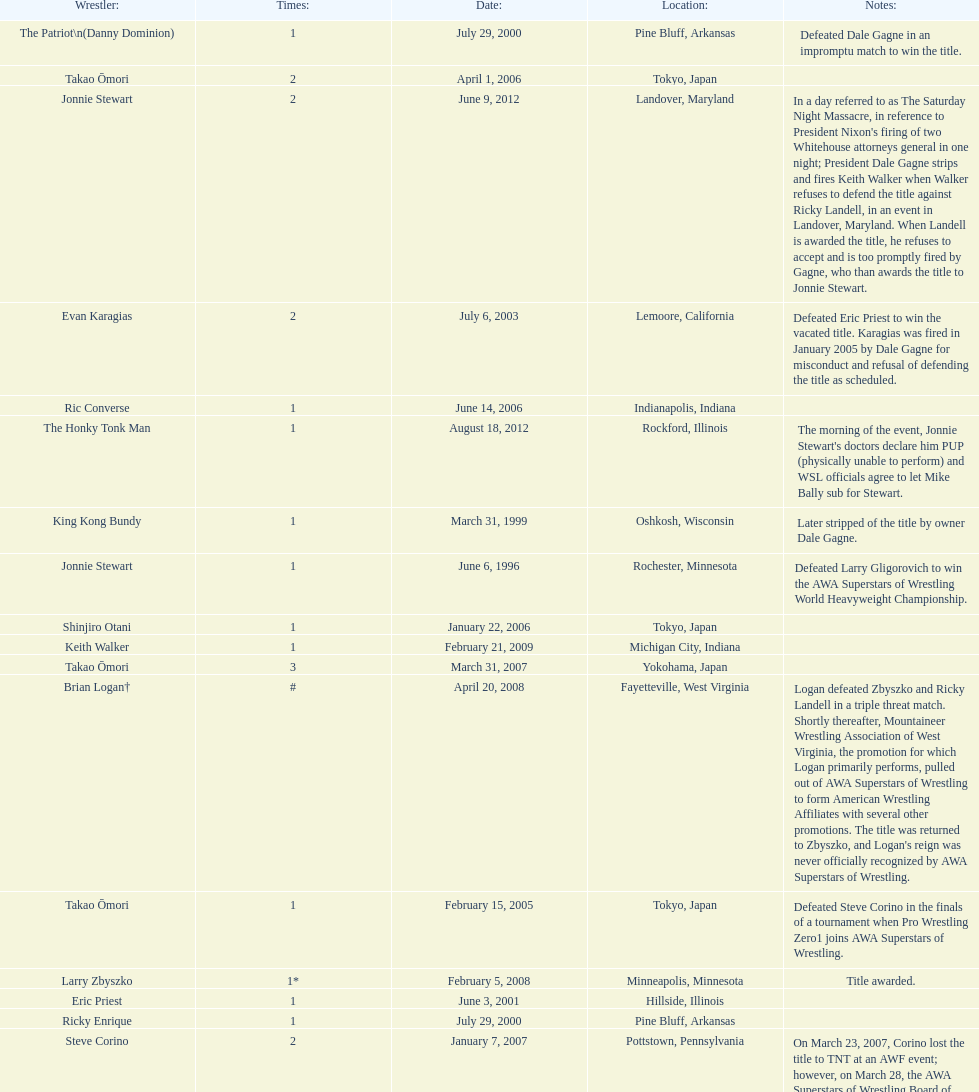What are the number of matches that happened in japan? 5. 